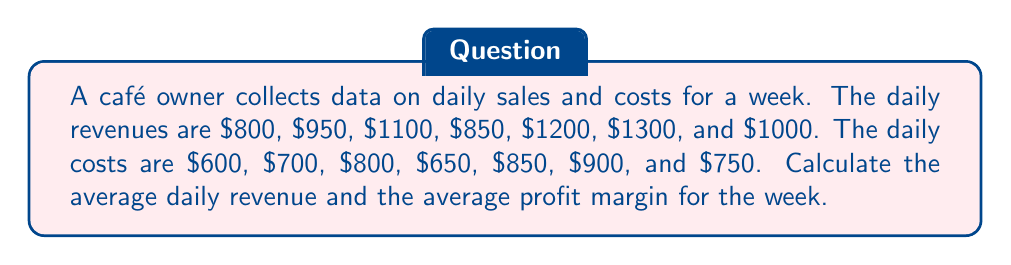Can you solve this math problem? 1. Calculate the average daily revenue:
   Sum of daily revenues: $800 + $950 + $1100 + $850 + $1200 + $1300 + $1000 = $7200
   Number of days: 7
   Average daily revenue: $$\frac{7200}{7} = $1028.57$$

2. Calculate the daily profits:
   Day 1: $800 - $600 = $200
   Day 2: $950 - $700 = $250
   Day 3: $1100 - $800 = $300
   Day 4: $850 - $650 = $200
   Day 5: $1200 - $850 = $350
   Day 6: $1300 - $900 = $400
   Day 7: $1000 - $750 = $250

3. Calculate the average daily profit:
   Sum of daily profits: $200 + $250 + $300 + $200 + $350 + $400 + $250 = $1950
   Average daily profit: $$\frac{1950}{7} = $278.57$$

4. Calculate the average profit margin:
   Profit margin = (Profit / Revenue) × 100%
   Average profit margin: $$\frac{278.57}{1028.57} \times 100\% = 27.08\%$$
Answer: $1028.57; 27.08% 